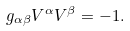<formula> <loc_0><loc_0><loc_500><loc_500>g _ { \alpha \beta } V ^ { \alpha } V ^ { \beta } = - 1 .</formula> 